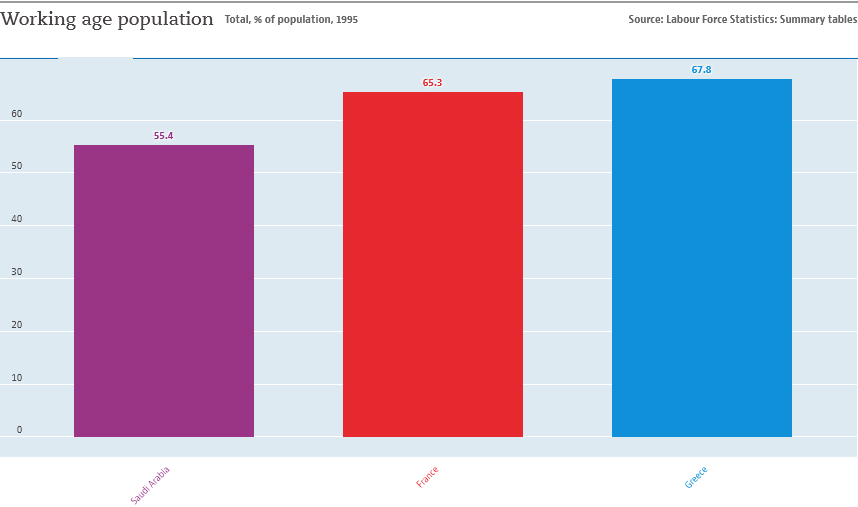Outline some significant characteristics in this image. The value of France is not greater than that of Greece. The number of color bars displayed in the graph is three. 